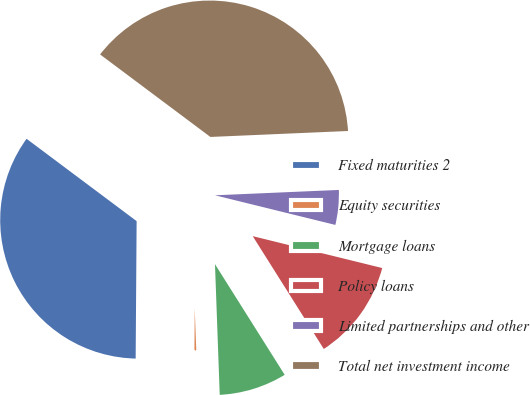Convert chart to OTSL. <chart><loc_0><loc_0><loc_500><loc_500><pie_chart><fcel>Fixed maturities 2<fcel>Equity securities<fcel>Mortgage loans<fcel>Policy loans<fcel>Limited partnerships and other<fcel>Total net investment income<nl><fcel>35.11%<fcel>0.69%<fcel>8.37%<fcel>12.21%<fcel>4.53%<fcel>39.09%<nl></chart> 